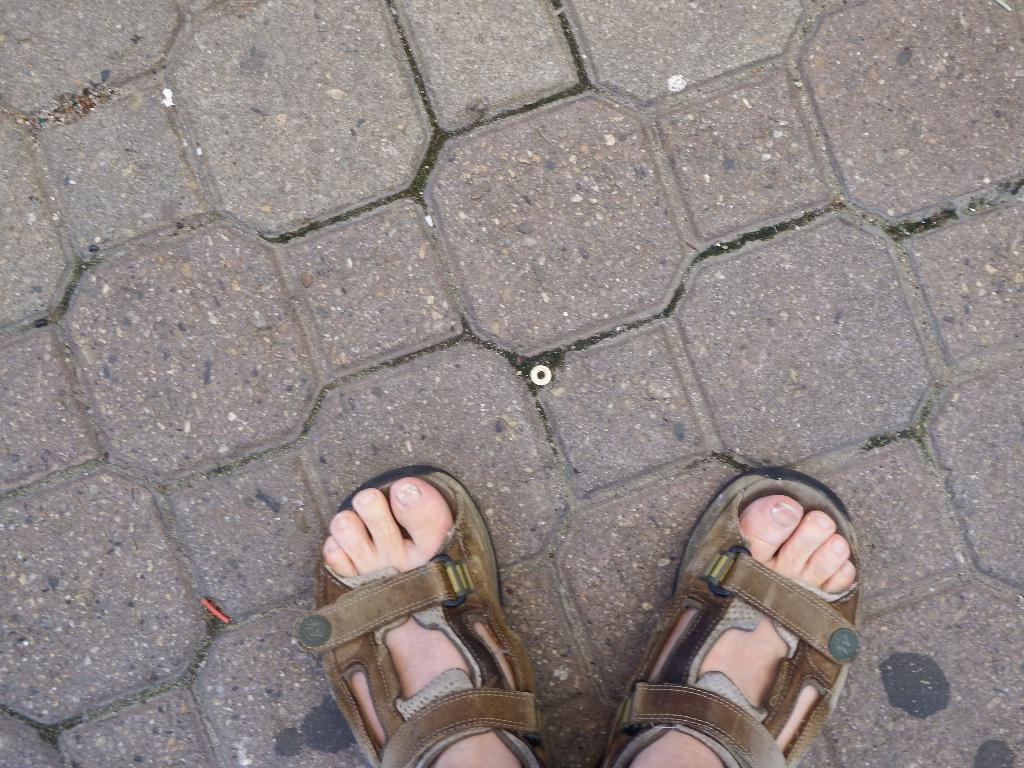What is the main subject in the foreground of the image? The main subject in the foreground of the image is the foot of a person. What is the foot doing in the image? The foot is on the ground. What type of stamp can be seen on the foot in the image? There is no stamp present on the foot in the image. What type of engine is visible on the foot in the image? There is no engine present on the foot in the image. 